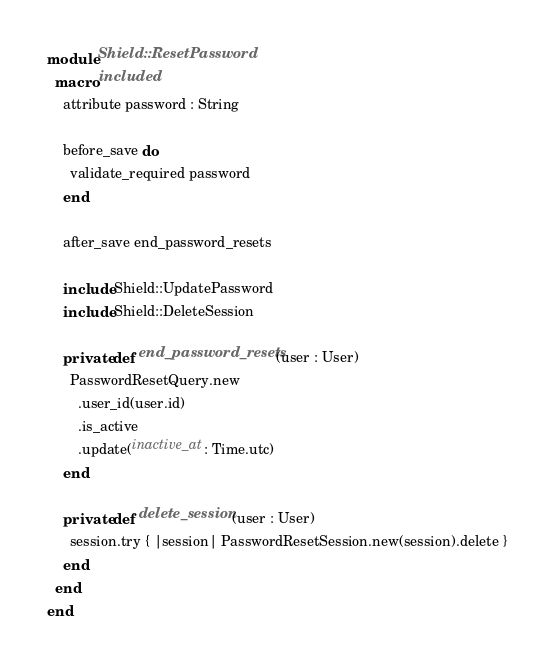Convert code to text. <code><loc_0><loc_0><loc_500><loc_500><_Crystal_>module Shield::ResetPassword
  macro included
    attribute password : String

    before_save do
      validate_required password
    end

    after_save end_password_resets

    include Shield::UpdatePassword
    include Shield::DeleteSession

    private def end_password_resets(user : User)
      PasswordResetQuery.new
        .user_id(user.id)
        .is_active
        .update(inactive_at: Time.utc)
    end

    private def delete_session(user : User)
      session.try { |session| PasswordResetSession.new(session).delete }
    end
  end
end
</code> 